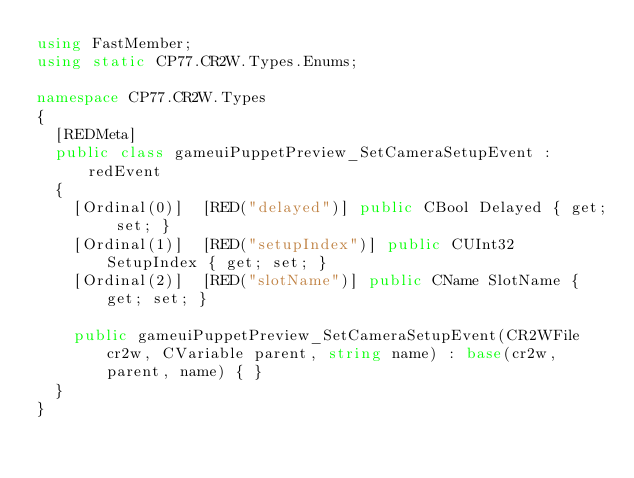Convert code to text. <code><loc_0><loc_0><loc_500><loc_500><_C#_>using FastMember;
using static CP77.CR2W.Types.Enums;

namespace CP77.CR2W.Types
{
	[REDMeta]
	public class gameuiPuppetPreview_SetCameraSetupEvent : redEvent
	{
		[Ordinal(0)]  [RED("delayed")] public CBool Delayed { get; set; }
		[Ordinal(1)]  [RED("setupIndex")] public CUInt32 SetupIndex { get; set; }
		[Ordinal(2)]  [RED("slotName")] public CName SlotName { get; set; }

		public gameuiPuppetPreview_SetCameraSetupEvent(CR2WFile cr2w, CVariable parent, string name) : base(cr2w, parent, name) { }
	}
}
</code> 